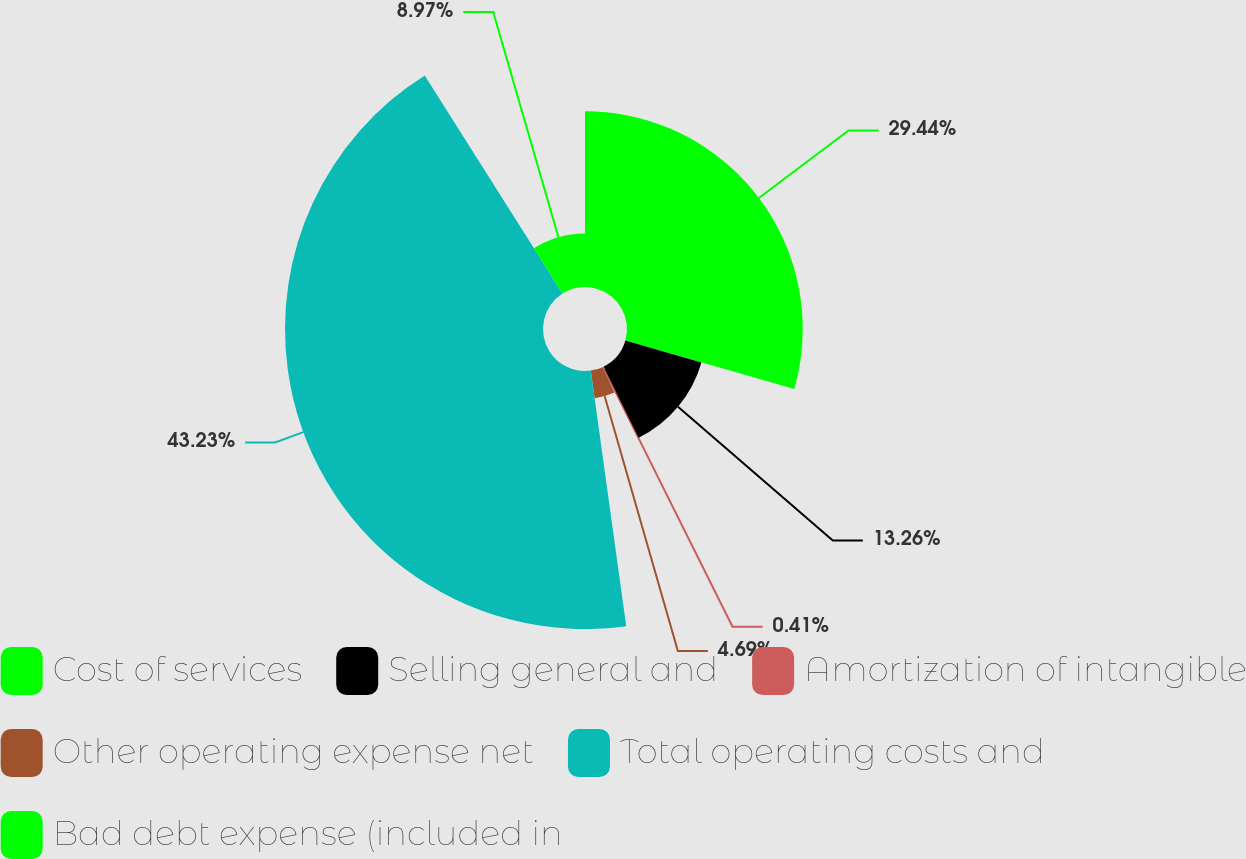Convert chart. <chart><loc_0><loc_0><loc_500><loc_500><pie_chart><fcel>Cost of services<fcel>Selling general and<fcel>Amortization of intangible<fcel>Other operating expense net<fcel>Total operating costs and<fcel>Bad debt expense (included in<nl><fcel>29.44%<fcel>13.26%<fcel>0.41%<fcel>4.69%<fcel>43.22%<fcel>8.97%<nl></chart> 